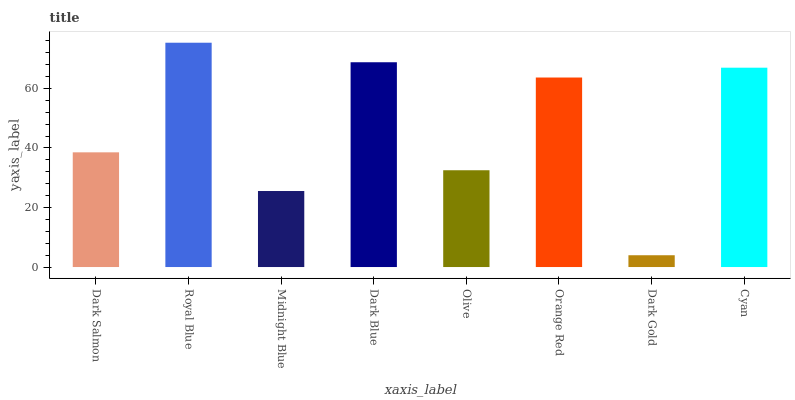Is Dark Gold the minimum?
Answer yes or no. Yes. Is Royal Blue the maximum?
Answer yes or no. Yes. Is Midnight Blue the minimum?
Answer yes or no. No. Is Midnight Blue the maximum?
Answer yes or no. No. Is Royal Blue greater than Midnight Blue?
Answer yes or no. Yes. Is Midnight Blue less than Royal Blue?
Answer yes or no. Yes. Is Midnight Blue greater than Royal Blue?
Answer yes or no. No. Is Royal Blue less than Midnight Blue?
Answer yes or no. No. Is Orange Red the high median?
Answer yes or no. Yes. Is Dark Salmon the low median?
Answer yes or no. Yes. Is Dark Blue the high median?
Answer yes or no. No. Is Cyan the low median?
Answer yes or no. No. 